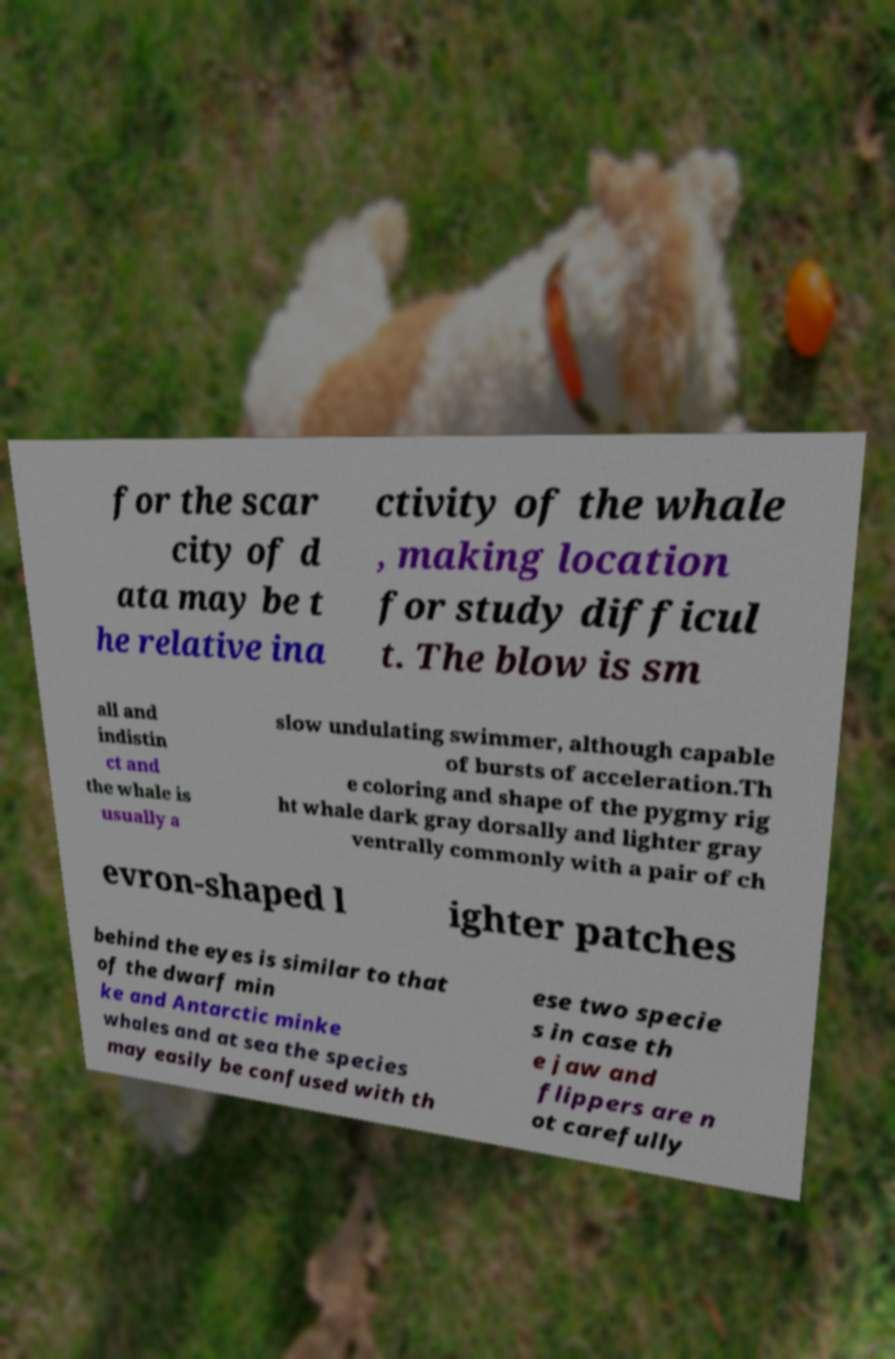Could you extract and type out the text from this image? for the scar city of d ata may be t he relative ina ctivity of the whale , making location for study difficul t. The blow is sm all and indistin ct and the whale is usually a slow undulating swimmer, although capable of bursts of acceleration.Th e coloring and shape of the pygmy rig ht whale dark gray dorsally and lighter gray ventrally commonly with a pair of ch evron-shaped l ighter patches behind the eyes is similar to that of the dwarf min ke and Antarctic minke whales and at sea the species may easily be confused with th ese two specie s in case th e jaw and flippers are n ot carefully 